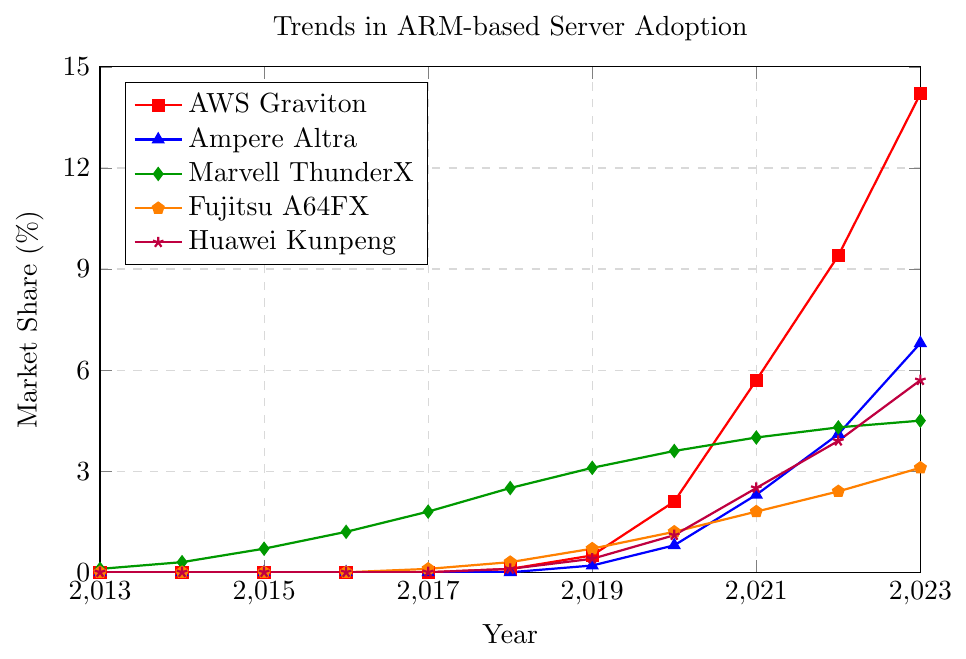What trend is observed in the market share of AWS Graviton from 2013 to 2023? The line for AWS Graviton starts at 0% in 2013, shows a steady increase, and reaches approximately 14.2% by 2023.
Answer: Increase How does the market share of Huawei Kunpeng in 2023 compare to that of Ampere Altra? In 2023, Huawei Kunpeng has a market share of 5.7%, while Ampere Altra has 6.8%. Thus, Ampere Altra has a higher market share than Huawei Kunpeng in 2023.
Answer: Ampere Altra is higher Which ARM-based server has the highest growth rate between 2019 and 2023? Looking at the steepness of the lines from 2019 to 2023, AWS Graviton shows the steepest increase, indicating the highest growth rate. AWS Graviton increased from 0.5% to 14.2%, a growth of 13.7%.
Answer: AWS Graviton What is the difference in market share between Marvell ThunderX and Fujitsu A64FX in 2020? In 2020, Marvell ThunderX has a market share of 3.6% and Fujitsu A64FX has 1.2%. The difference is calculated as 3.6% - 1.2% = 2.4%.
Answer: 2.4% Which two ARM-based servers had an introduction year, as shown by their first non-zero market share, and what year did they appear? Both Fujitsu A64FX and Huawei Kunpeng had their first non-zero market share in 2017 and 2018 respectively. UFOJIPO
Answer: Fujitsu A64FX in 2017 and Huawei Kunpeng in 2018 What is the average market share of Marvell ThunderX from 2013 to 2023? To find the average, sum the market shares of Marvell ThunderX for each year and divide by the total number of years (11): (0.1+0.3+0.7+1.2+1.8+2.5+3.1+3.6+4.0+4.3+4.5)/11 = 2.82/11 = 2.18%.
Answer: 2.18% Compare the market shares of AWS Graviton and Ampere Altra in 2021. Which one is higher, and by how much? In 2021, AWS Graviton has a market share of 5.7%, while Ampere Altra has 2.3%. The difference is 5.7% - 2.3% = 3.4%.
Answer: AWS Graviton is higher by 3.4% Which server had a constant growth rate from 2013 to 2023, and what was the rate per year? Marvell ThunderX shows a consistent growth, increasing from 0.1% in 2013 to 4.5% in 2023. The growth per year is (4.5% - 0.1%) / (2023 - 2013) = 4.4% / 10 = 0.44% per year.
Answer: Marvell ThunderX at 0.44% per year What is the maximum market share achieved by Fujitsu A64FX, and in which year? The maximum market share achieved by Fujitsu A64FX is 3.1% in 2023.
Answer: 3.1% in 2023 